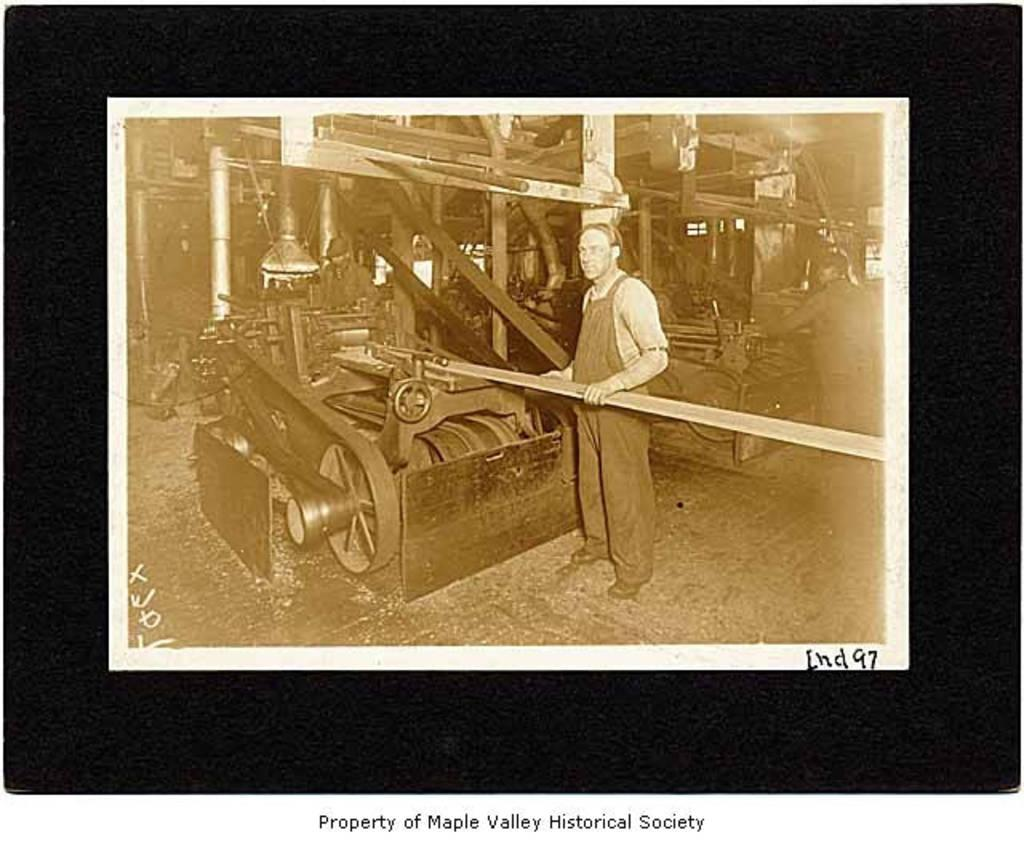What is the main subject of the image? The main subject of the image is a photograph on a black surface. What can be seen in the photograph? The photograph contains people, machines, and objects. Is there any text present in the photograph? Yes, there is text in the photograph. How many frogs are visible in the photograph? There are no frogs visible in the photograph; it contains people, machines, and objects. What type of salt is used to season the people in the photograph? There is no salt or seasoning present in the photograph; it only contains people, machines, and objects. 